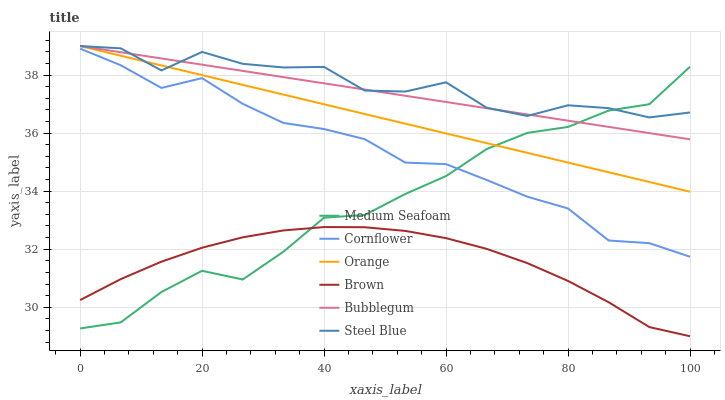Does Brown have the minimum area under the curve?
Answer yes or no. Yes. Does Steel Blue have the maximum area under the curve?
Answer yes or no. Yes. Does Steel Blue have the minimum area under the curve?
Answer yes or no. No. Does Brown have the maximum area under the curve?
Answer yes or no. No. Is Orange the smoothest?
Answer yes or no. Yes. Is Steel Blue the roughest?
Answer yes or no. Yes. Is Brown the smoothest?
Answer yes or no. No. Is Brown the roughest?
Answer yes or no. No. Does Brown have the lowest value?
Answer yes or no. Yes. Does Steel Blue have the lowest value?
Answer yes or no. No. Does Orange have the highest value?
Answer yes or no. Yes. Does Brown have the highest value?
Answer yes or no. No. Is Cornflower less than Bubblegum?
Answer yes or no. Yes. Is Orange greater than Cornflower?
Answer yes or no. Yes. Does Orange intersect Steel Blue?
Answer yes or no. Yes. Is Orange less than Steel Blue?
Answer yes or no. No. Is Orange greater than Steel Blue?
Answer yes or no. No. Does Cornflower intersect Bubblegum?
Answer yes or no. No. 